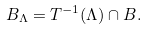Convert formula to latex. <formula><loc_0><loc_0><loc_500><loc_500>B _ { \Lambda } = T ^ { - 1 } ( \Lambda ) \cap B .</formula> 